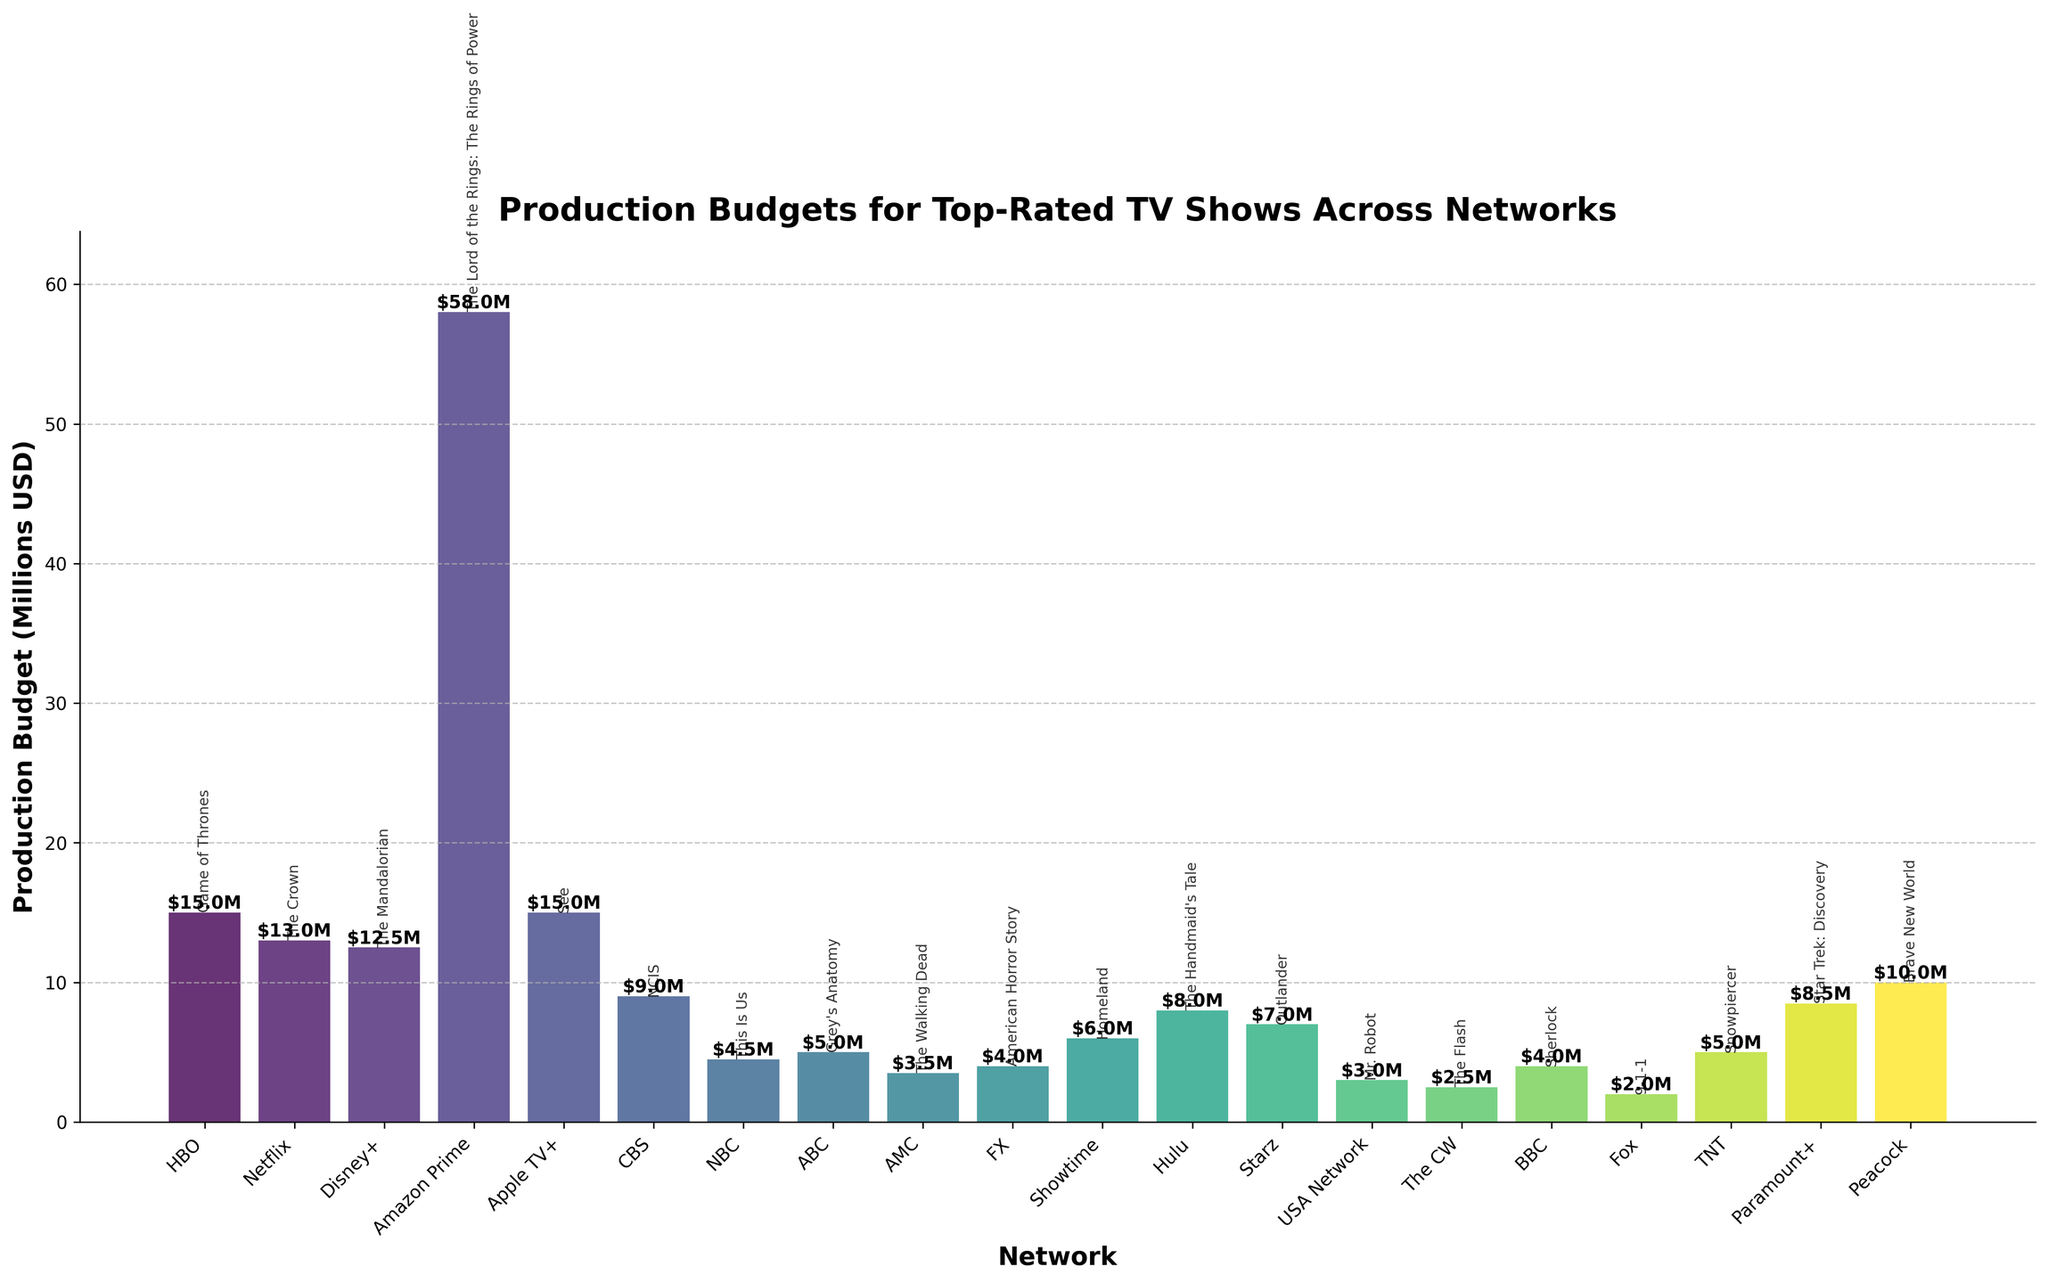Which network has the highest production budget for its show? By examining the height of the bars, the Amazon Prime bar is the tallest, indicating the highest production budget.
Answer: Amazon Prime Which network has the lowest production budget for its show? The smallest bar is the one for Fox, indicating it has the lowest production budget.
Answer: Fox How much more is the production budget of 'The Lord of the Rings: The Rings of Power' than 'The Flash'? The height of 'The Lord of the Rings: The Rings of Power' bar is 58, and 'The Flash' bar is 2.5. The difference is 58 - 2.5.
Answer: 55.5 What is the total production budget for the shows on streaming networks (HBO, Netflix, Disney+, Amazon Prime, Apple TV+, Hulu, Paramount+, Peacock)? Summing the budgets: 15 (HBO) + 13 (Netflix) + 12.5 (Disney+) + 58 (Amazon Prime) + 15 (Apple TV+) + 8 (Hulu) + 8.5 (Paramount+) + 10 (Peacock) = 140
Answer: 140 What is the average production budget of all the shows across the networks? There are 20 shows. Sum all their budgets: 15 + 13 + 12.5 + 58 + 15 + 9 + 4.5 + 5 + 3.5 + 4 + 6 + 8 + 7 + 3 + 2.5 + 4 + 2 + 5 + 8.5 + 10 = 191.5. The average is 191.5 / 20.
Answer: 9.575 Which network's top-rated show has a production budget closest to the average budget? The average production budget is 9.575. The closest budgets are for CBS (NCIS) at 9 and Paramount+ (Star Trek: Discovery) at 8.5. Paramount+ is slightly closer (1.075 vs 0.575).
Answer: Paramount+ Is the production budget for 'See' from Apple TV+ greater than or less than the budget for 'The Crown' from Netflix? 'See' has a production budget of 15, while 'The Crown' has 13. Therefore, 'See' has a greater budget.
Answer: Greater How does the production budget for 'NCIS' compare to 'Homeland'? 'NCIS' has a budget of 9 and 'Homeland' has 6. Therefore, 'NCIS' has a higher budget.
Answer: Higher What are the production budgets for all TV shows with budgets under $5 million? Identifying the shows below $5M: NBC-This Is Us (4.5), AMC-The Walking Dead (3.5), FX-American Horror Story (4), USA Network-Mr. Robot (3), The CW-The Flash (2.5), BBC-Sherlock (4), Fox-9-1-1 (2).
Answer: This Is Us (4.5), The Walking Dead (3.5), American Horror Story (4), Mr. Robot (3), The Flash (2.5), Sherlock (4), 9-1-1 (2) By how much does 'Game of Thrones' exceed the average production budget? 'Game of Thrones' has a budget of 15. The average budget is 9.575. The difference is 15 - 9.575.
Answer: 5.425 